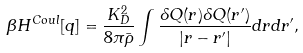<formula> <loc_0><loc_0><loc_500><loc_500>\beta H ^ { C o u l } [ q ] = \frac { K _ { D } ^ { 2 } } { 8 \pi \bar { \rho } } \int \frac { \delta Q ( { r } ) \delta Q ( { r ^ { \prime } } ) } { | { r } - { r ^ { \prime } } | } d { r } d { r ^ { \prime } } ,</formula> 